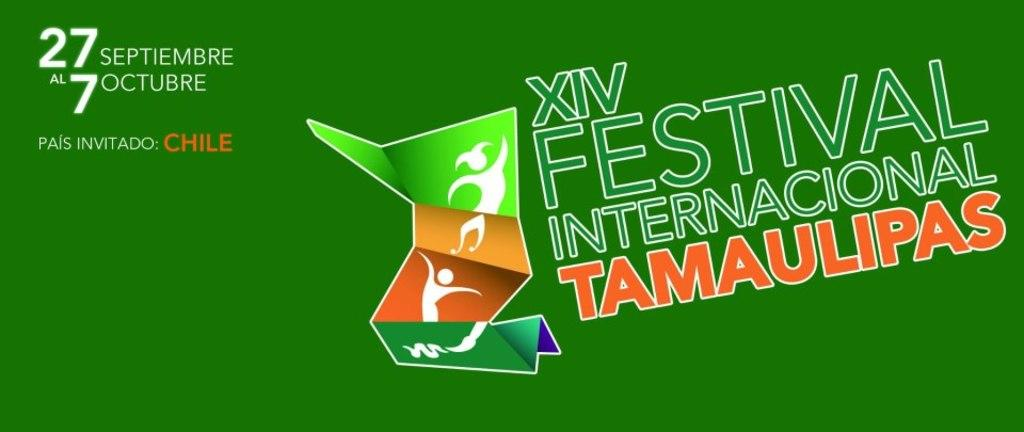<image>
Create a compact narrative representing the image presented. ad from xiv festival internacional tamaulipas om green 